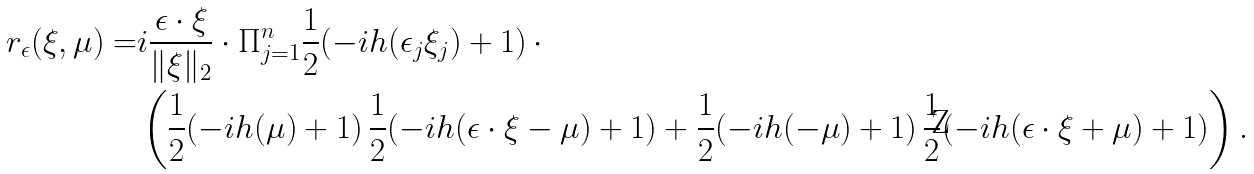Convert formula to latex. <formula><loc_0><loc_0><loc_500><loc_500>r _ { \epsilon } ( \xi , \mu ) = & i \frac { \epsilon \cdot \xi } { \| \xi \| _ { 2 } } \cdot \Pi _ { j = 1 } ^ { n } \frac { 1 } { 2 } ( - i h ( \epsilon _ { j } \xi _ { j } ) + 1 ) \, \cdot \, \\ & \left ( \frac { 1 } { 2 } ( - i h ( \mu ) + 1 ) \, \frac { 1 } { 2 } ( - i h ( \epsilon \cdot \xi - \mu ) + 1 ) + \frac { 1 } { 2 } ( - i h ( - \mu ) + 1 ) \, \frac { 1 } { 2 } ( - i h ( \epsilon \cdot \xi + \mu ) + 1 ) \right ) .</formula> 